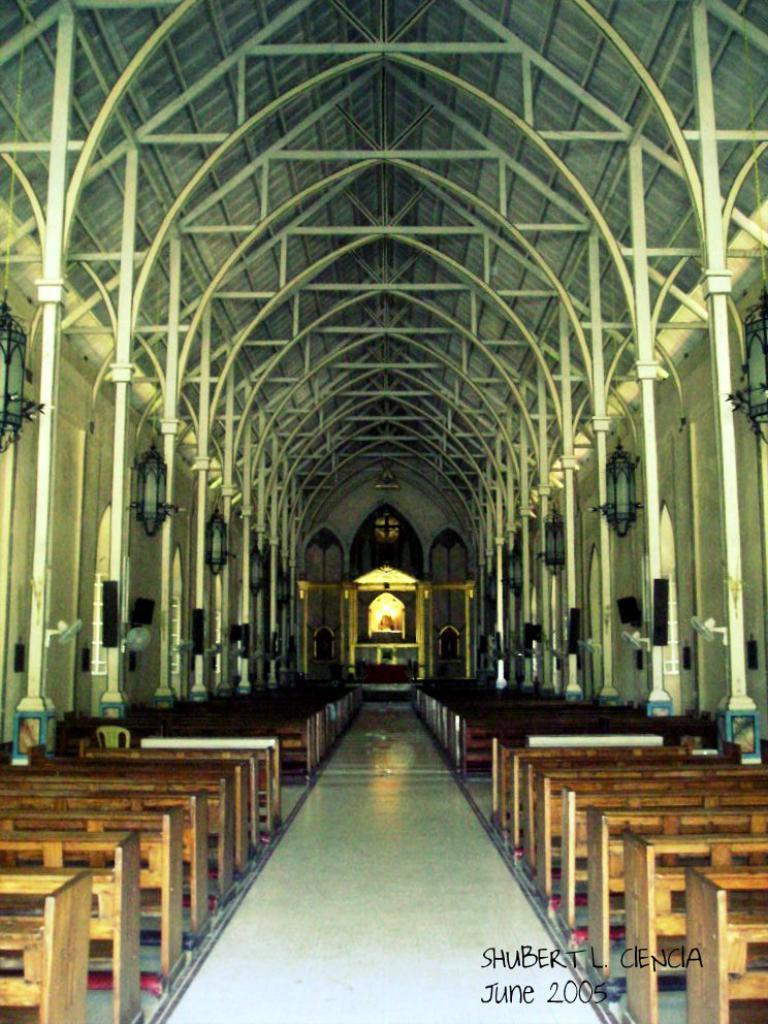<image>
Summarize the visual content of the image. Shubert L. Cienca photographed a church in June of 2005 that has cathedral ceilings and can easily fit 100 people. 